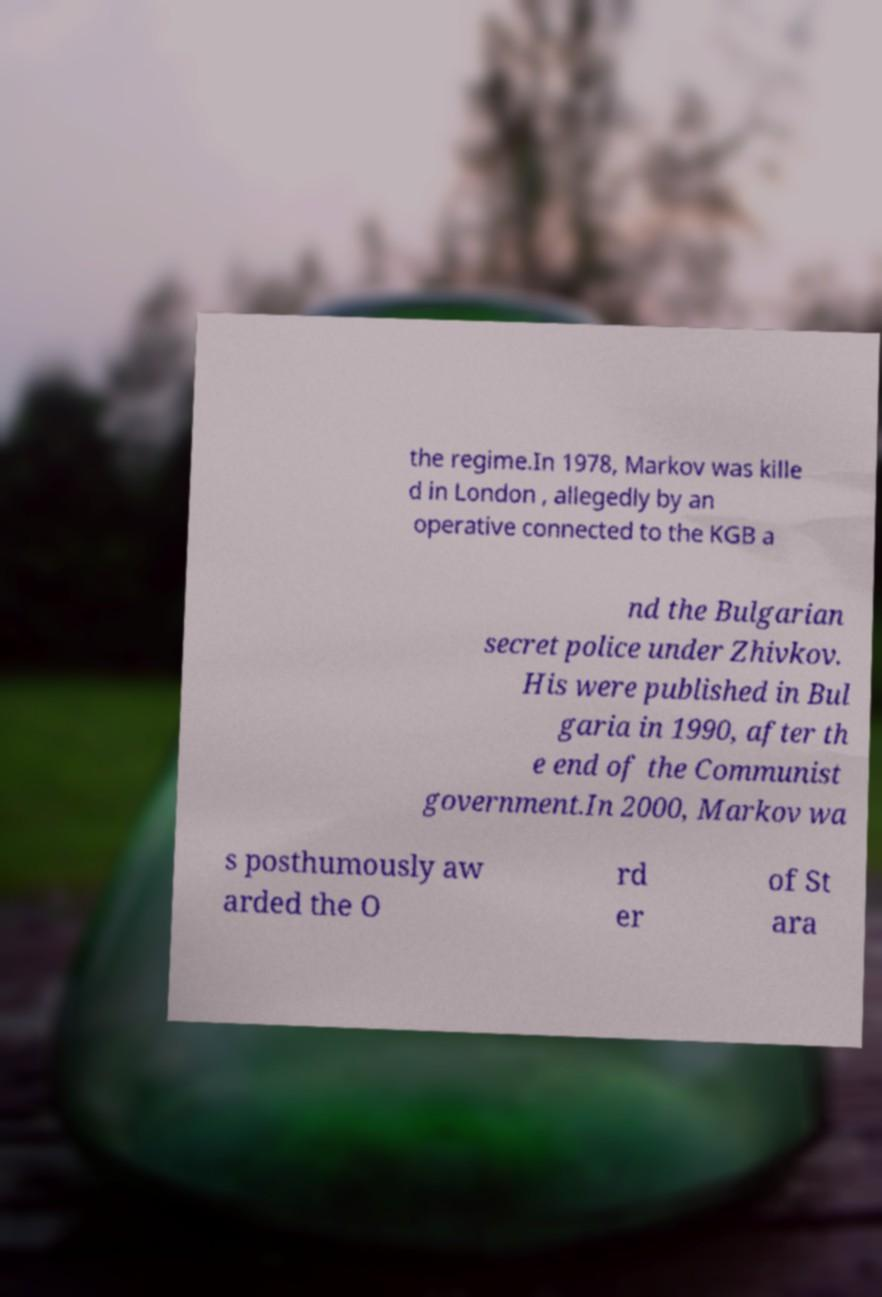There's text embedded in this image that I need extracted. Can you transcribe it verbatim? the regime.In 1978, Markov was kille d in London , allegedly by an operative connected to the KGB a nd the Bulgarian secret police under Zhivkov. His were published in Bul garia in 1990, after th e end of the Communist government.In 2000, Markov wa s posthumously aw arded the O rd er of St ara 